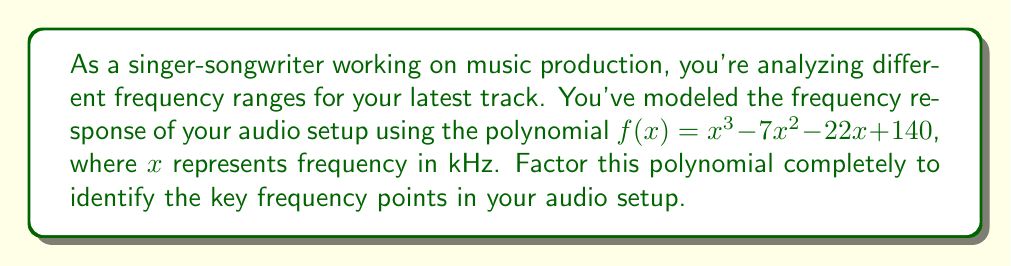Could you help me with this problem? Let's approach this step-by-step:

1) First, we'll check if there are any rational roots using the rational root theorem. The possible rational roots are the factors of the constant term: $\pm 1, \pm 2, \pm 4, \pm 5, \pm 7, \pm 10, \pm 14, \pm 20, \pm 28, \pm 35, \pm 70, \pm 140$.

2) Testing these values, we find that $f(5) = 0$. So $(x-5)$ is a factor.

3) We can use polynomial long division to divide $f(x)$ by $(x-5)$:

   $$\frac{x^3 - 7x^2 - 22x + 140}{x - 5} = x^2 - 2x - 28$$

4) Now we have: $f(x) = (x-5)(x^2 - 2x - 28)$

5) We need to factor the quadratic term $x^2 - 2x - 28$. We can do this by finding two numbers that multiply to give $-28$ and add to give $-2$.

6) These numbers are $-7$ and $5$. So we can rewrite the quadratic as:

   $x^2 - 2x - 28 = (x-7)(x+5)$

7) Therefore, the complete factorization is:

   $f(x) = (x-5)(x-7)(x+5)$

This factorization reveals that the key frequency points in your audio setup are at 5 kHz, 7 kHz, and -5 kHz (although negative frequency doesn't have a physical meaning in this context, it's part of the mathematical solution).
Answer: $f(x) = (x-5)(x-7)(x+5)$ 